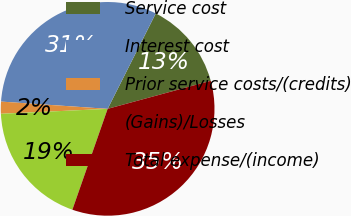Convert chart. <chart><loc_0><loc_0><loc_500><loc_500><pie_chart><fcel>Service cost<fcel>Interest cost<fcel>Prior service costs/(credits)<fcel>(Gains)/Losses<fcel>Total expense/(income)<nl><fcel>13.34%<fcel>31.35%<fcel>1.82%<fcel>18.91%<fcel>34.58%<nl></chart> 